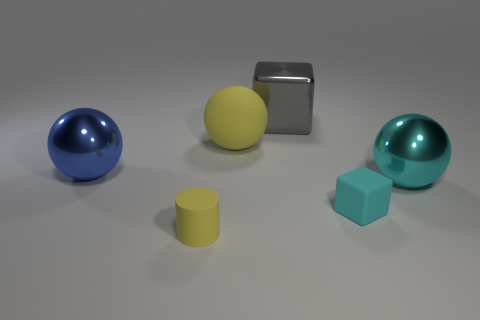Add 3 small brown matte spheres. How many objects exist? 9 Subtract all blocks. How many objects are left? 4 Add 2 small brown spheres. How many small brown spheres exist? 2 Subtract 1 cyan balls. How many objects are left? 5 Subtract all small yellow cylinders. Subtract all blue things. How many objects are left? 4 Add 2 big gray objects. How many big gray objects are left? 3 